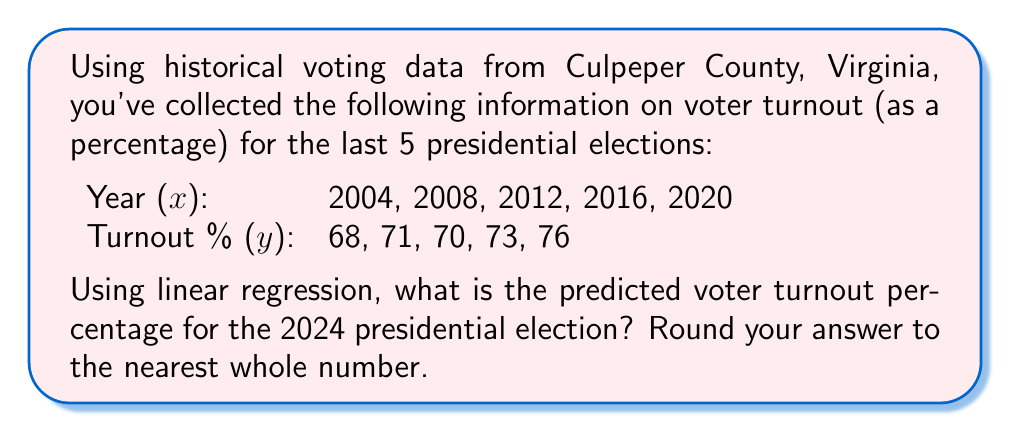Give your solution to this math problem. To solve this problem using linear regression, we'll follow these steps:

1) First, we need to calculate the means of x and y:
   $\bar{x} = \frac{2004 + 2008 + 2012 + 2016 + 2020}{5} = 2012$
   $\bar{y} = \frac{68 + 71 + 70 + 73 + 76}{5} = 71.6$

2) Now, we'll calculate the slope (m) using the formula:
   $m = \frac{\sum(x_i - \bar{x})(y_i - \bar{y})}{\sum(x_i - \bar{x})^2}$

3) Let's create a table to help with calculations:

   | x    | y  | x - x̄ | y - ȳ | (x - x̄)(y - ȳ) | (x - x̄)^2 |
   |------|----|-----------|-----------|--------------------|--------------|
   | 2004 | 68 | -8       | -3.6      | 28.8               | 64           |
   | 2008 | 71 | -4       | -0.6      | 2.4                | 16           |
   | 2012 | 70 | 0        | -1.6      | 0                  | 0            |
   | 2016 | 73 | 4        | 1.4       | 5.6                | 16           |
   | 2020 | 76 | 8        | 4.4       | 35.2               | 64           |
   |      |    |           |           | Σ = 72             | Σ = 160      |

4) Now we can calculate the slope:
   $m = \frac{72}{160} = 0.45$

5) We can find the y-intercept (b) using the formula:
   $b = \bar{y} - m\bar{x}$
   $b = 71.6 - 0.45(2012) = -833.8$

6) Our linear regression equation is:
   $y = 0.45x - 833.8$

7) To predict the turnout for 2024, we plug in x = 2024:
   $y = 0.45(2024) - 833.8 = 77.0$

8) Rounding to the nearest whole number, we get 77%.
Answer: 77% 